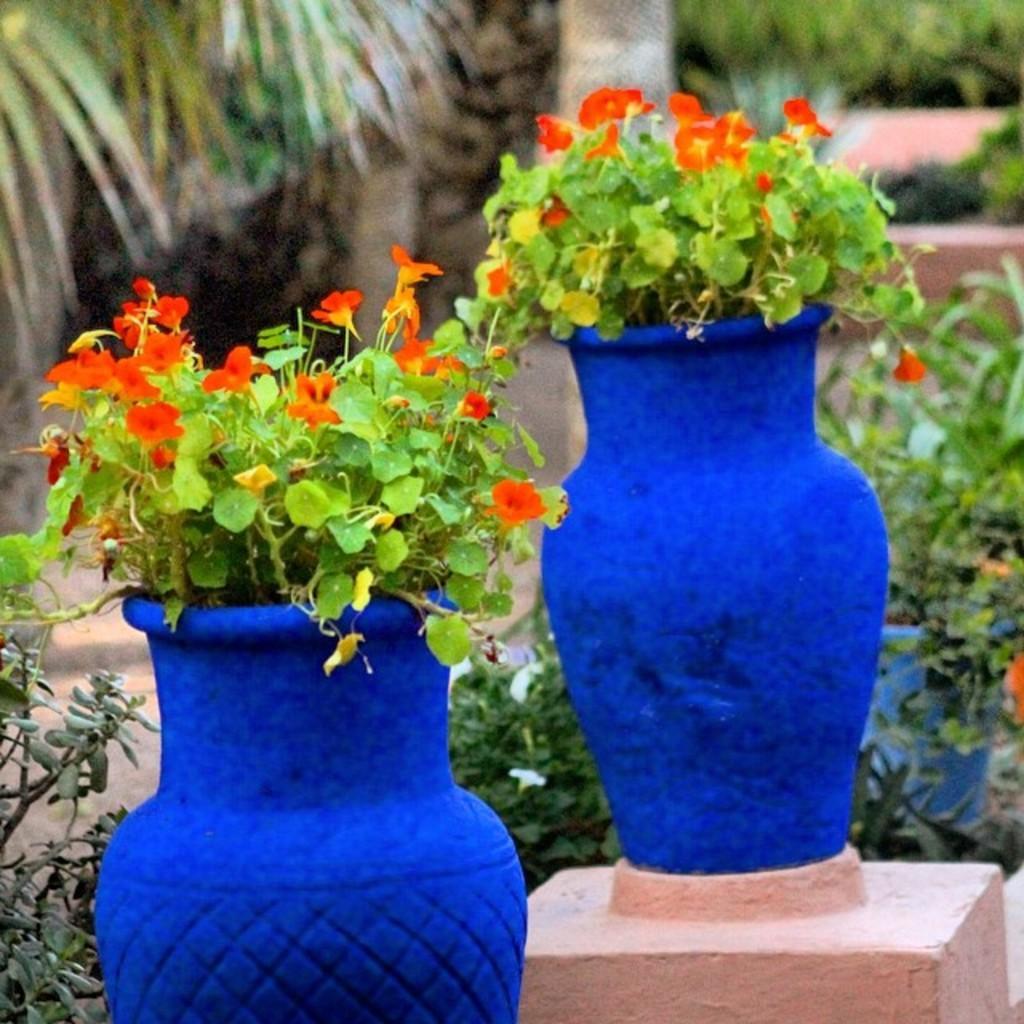Could you give a brief overview of what you see in this image? In the image we can see some plants. Behind the plants there are some trees. 